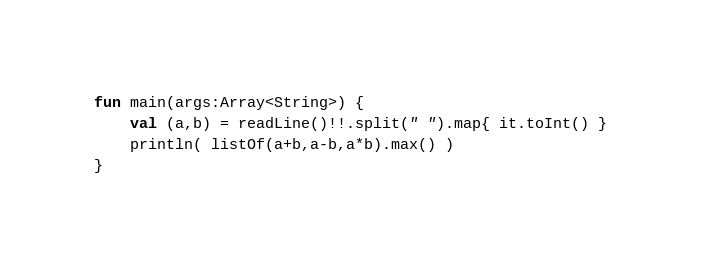<code> <loc_0><loc_0><loc_500><loc_500><_Kotlin_>fun main(args:Array<String>) {
	val (a,b) = readLine()!!.split(" ").map{ it.toInt() }
	println( listOf(a+b,a-b,a*b).max() )
}</code> 